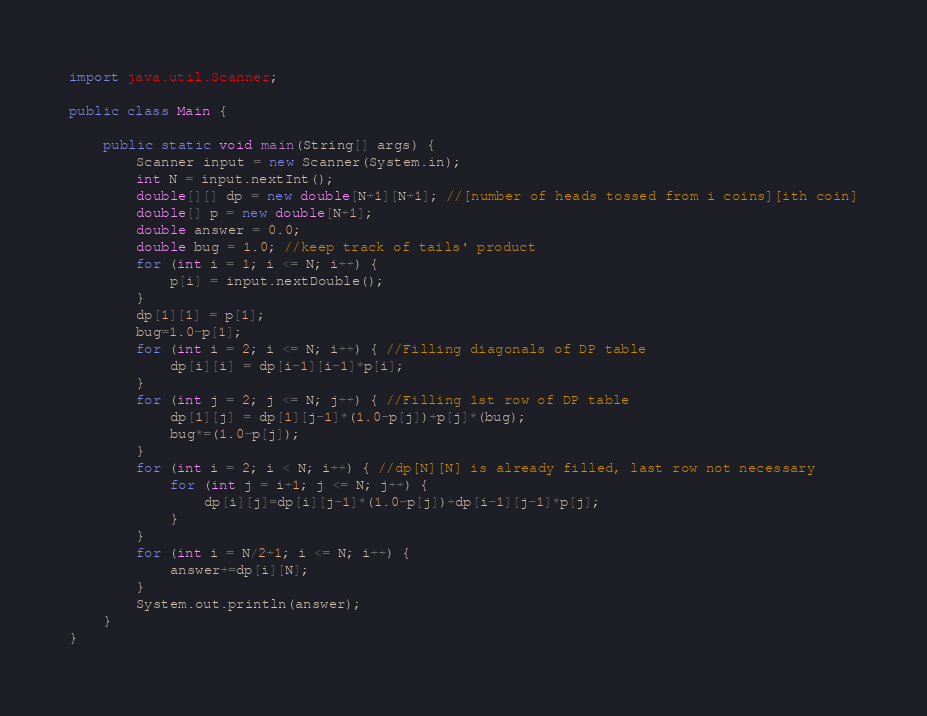Convert code to text. <code><loc_0><loc_0><loc_500><loc_500><_Java_>import java.util.Scanner;
 
public class Main {
 
	public static void main(String[] args) { 
		Scanner input = new Scanner(System.in);
		int N = input.nextInt();
		double[][] dp = new double[N+1][N+1]; //[number of heads tossed from i coins][ith coin]
		double[] p = new double[N+1];
		double answer = 0.0;
		double bug = 1.0; //keep track of tails' product
		for (int i = 1; i <= N; i++) {
			p[i] = input.nextDouble();
		}
		dp[1][1] = p[1];
		bug=1.0-p[1];
		for (int i = 2; i <= N; i++) { //Filling diagonals of DP table
			dp[i][i] = dp[i-1][i-1]*p[i];
		}
		for (int j = 2; j <= N; j++) { //Filling 1st row of DP table
			dp[1][j] = dp[1][j-1]*(1.0-p[j])+p[j]*(bug);
			bug*=(1.0-p[j]);
		}
		for (int i = 2; i < N; i++) { //dp[N][N] is already filled, last row not necessary
			for (int j = i+1; j <= N; j++) {
				dp[i][j]=dp[i][j-1]*(1.0-p[j])+dp[i-1][j-1]*p[j]; 
			}
		}
		for (int i = N/2+1; i <= N; i++) {
			answer+=dp[i][N];
		}
		System.out.println(answer);
	}
}</code> 